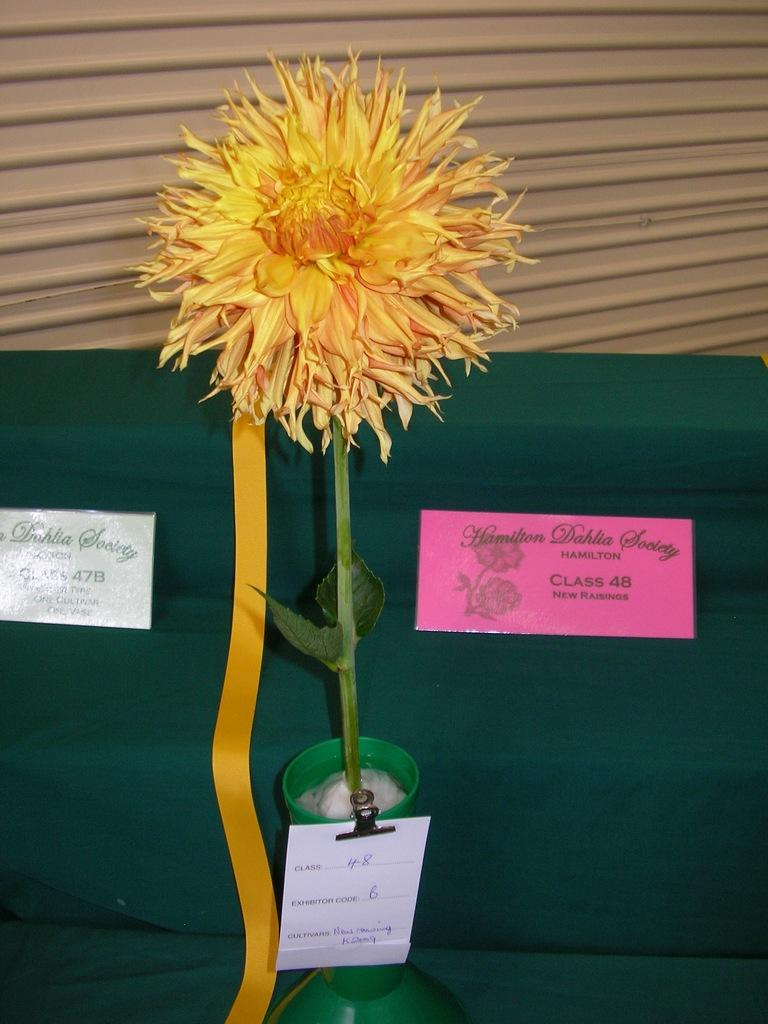What is the main object in the vase in the image? There is a flower in a vase in the image. What type of material can be seen in the image? There are boards and a green cloth visible in the image. What is visible in the background of the image? There is a shutter visible in the background of the image. How does the woman measure the length of the vase in the image? There is no woman present in the image, and therefore no such activity can be observed. 